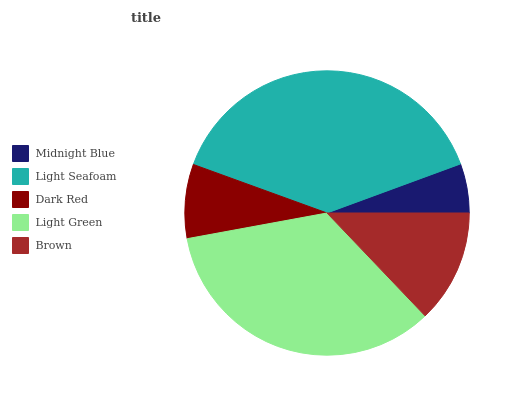Is Midnight Blue the minimum?
Answer yes or no. Yes. Is Light Seafoam the maximum?
Answer yes or no. Yes. Is Dark Red the minimum?
Answer yes or no. No. Is Dark Red the maximum?
Answer yes or no. No. Is Light Seafoam greater than Dark Red?
Answer yes or no. Yes. Is Dark Red less than Light Seafoam?
Answer yes or no. Yes. Is Dark Red greater than Light Seafoam?
Answer yes or no. No. Is Light Seafoam less than Dark Red?
Answer yes or no. No. Is Brown the high median?
Answer yes or no. Yes. Is Brown the low median?
Answer yes or no. Yes. Is Light Green the high median?
Answer yes or no. No. Is Light Green the low median?
Answer yes or no. No. 